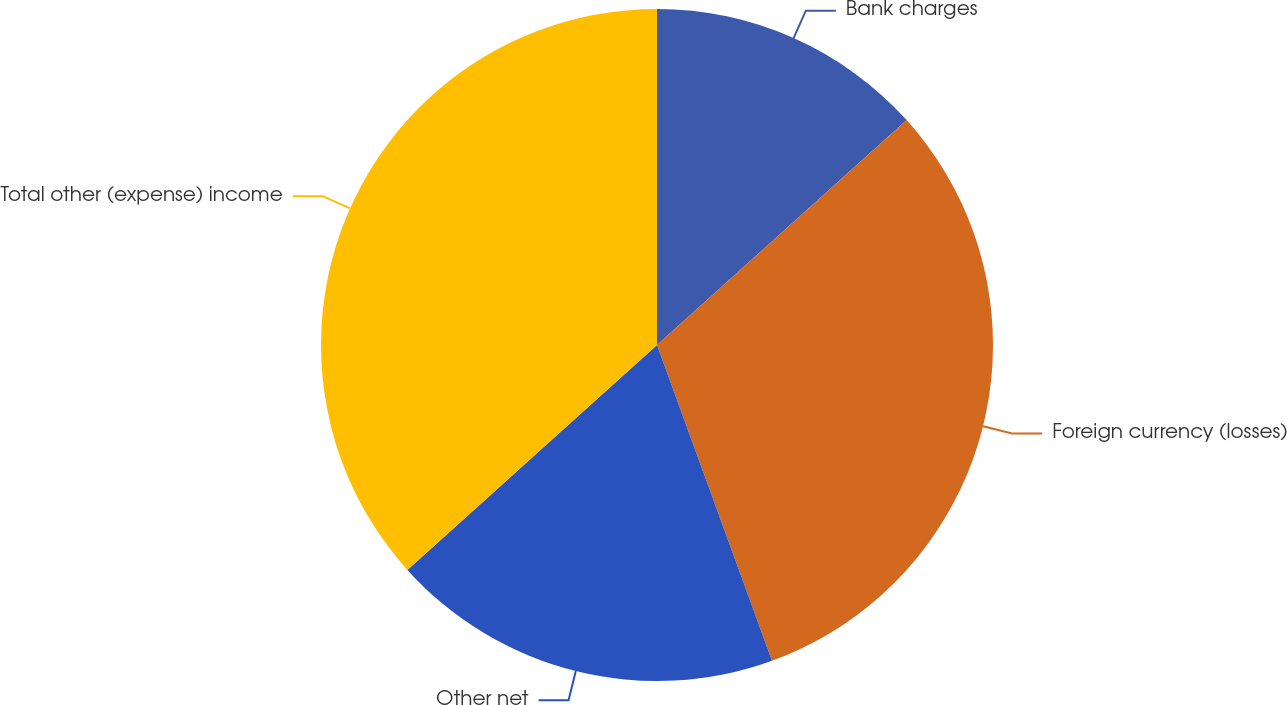Convert chart to OTSL. <chart><loc_0><loc_0><loc_500><loc_500><pie_chart><fcel>Bank charges<fcel>Foreign currency (losses)<fcel>Other net<fcel>Total other (expense) income<nl><fcel>13.33%<fcel>31.11%<fcel>18.89%<fcel>36.67%<nl></chart> 